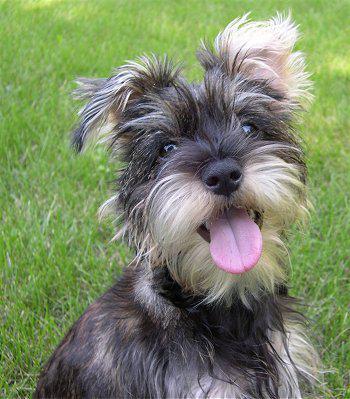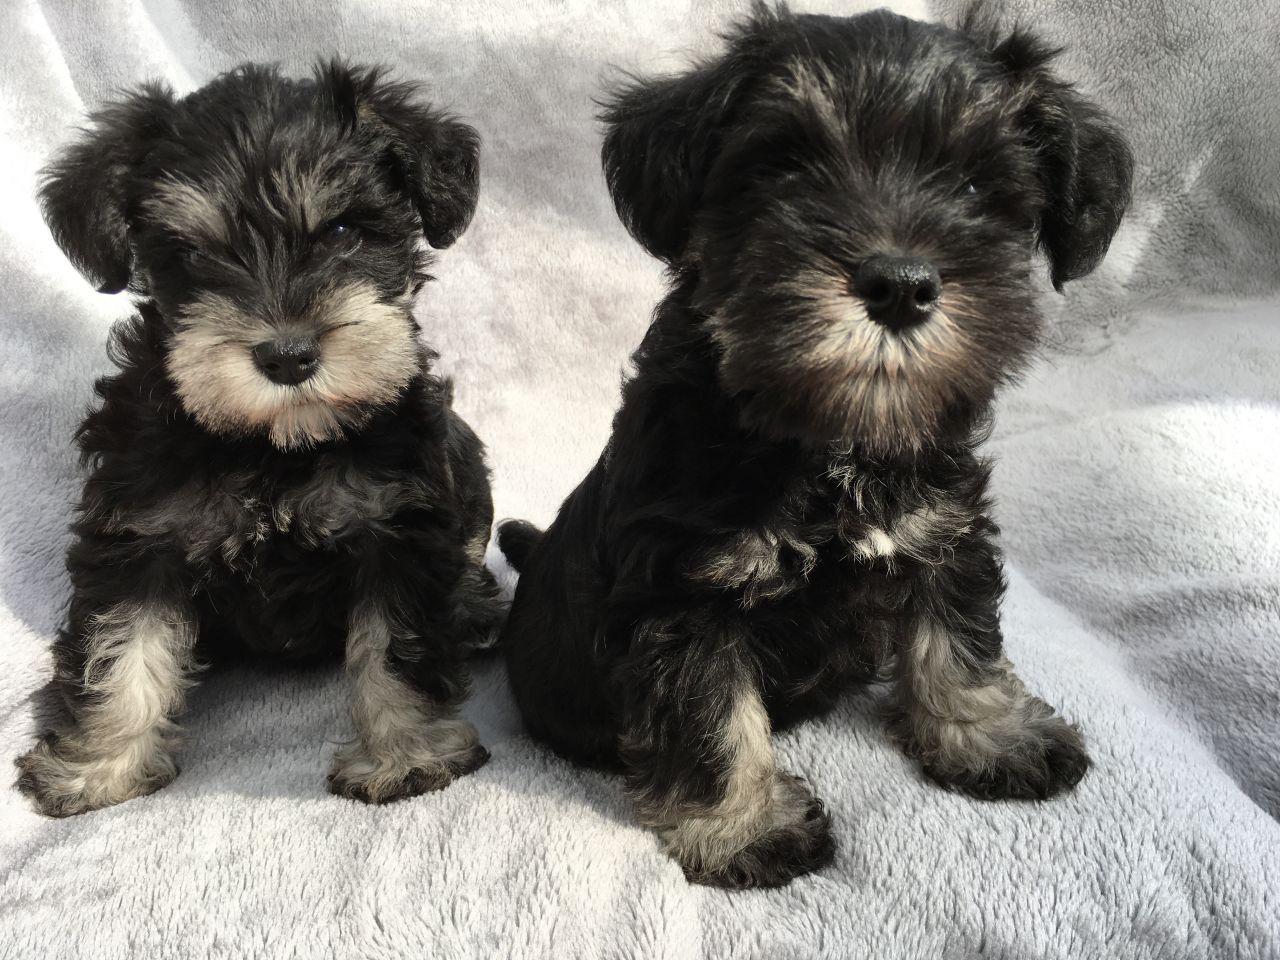The first image is the image on the left, the second image is the image on the right. Given the left and right images, does the statement "One of the images has two dogs that are sitting." hold true? Answer yes or no. Yes. The first image is the image on the left, the second image is the image on the right. Assess this claim about the two images: "There are at most two dogs.". Correct or not? Answer yes or no. No. 